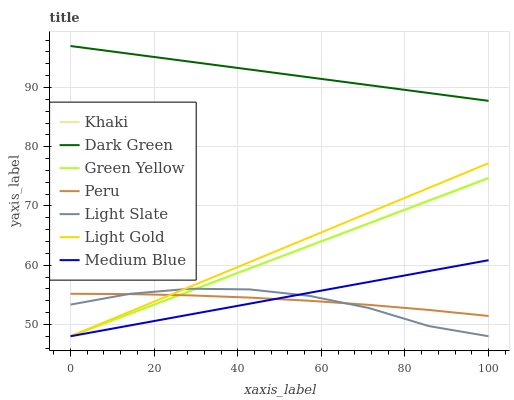Does Light Slate have the minimum area under the curve?
Answer yes or no. Yes. Does Dark Green have the maximum area under the curve?
Answer yes or no. Yes. Does Medium Blue have the minimum area under the curve?
Answer yes or no. No. Does Medium Blue have the maximum area under the curve?
Answer yes or no. No. Is Medium Blue the smoothest?
Answer yes or no. Yes. Is Light Slate the roughest?
Answer yes or no. Yes. Is Light Slate the smoothest?
Answer yes or no. No. Is Medium Blue the roughest?
Answer yes or no. No. Does Khaki have the lowest value?
Answer yes or no. Yes. Does Peru have the lowest value?
Answer yes or no. No. Does Dark Green have the highest value?
Answer yes or no. Yes. Does Light Slate have the highest value?
Answer yes or no. No. Is Green Yellow less than Dark Green?
Answer yes or no. Yes. Is Dark Green greater than Medium Blue?
Answer yes or no. Yes. Does Khaki intersect Peru?
Answer yes or no. Yes. Is Khaki less than Peru?
Answer yes or no. No. Is Khaki greater than Peru?
Answer yes or no. No. Does Green Yellow intersect Dark Green?
Answer yes or no. No. 